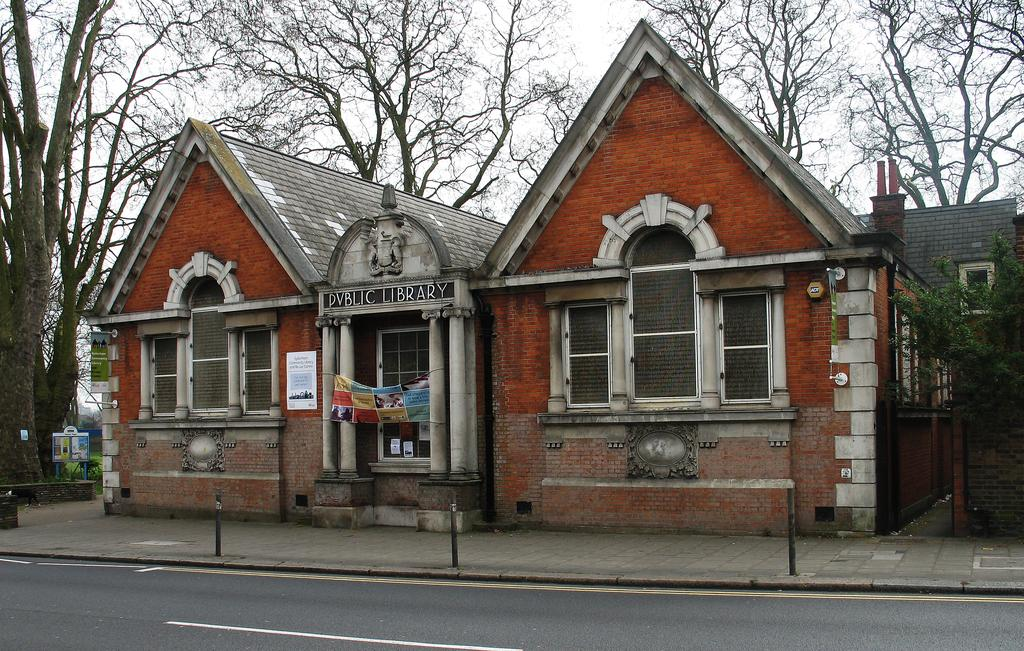What type of structures can be seen in the image? There are houses in the image. What feature is common to the houses and other structures in the image? There are windows in the image. What type of natural elements are present in the image? There are trees in the image. What additional element can be seen in the image? There is a banner in the image. What is visible in the background of the image? The sky is visible in the image. Where is the machine located in the image? There is no machine present in the image. What type of cemetery can be seen in the image? There is no cemetery present in the image. 